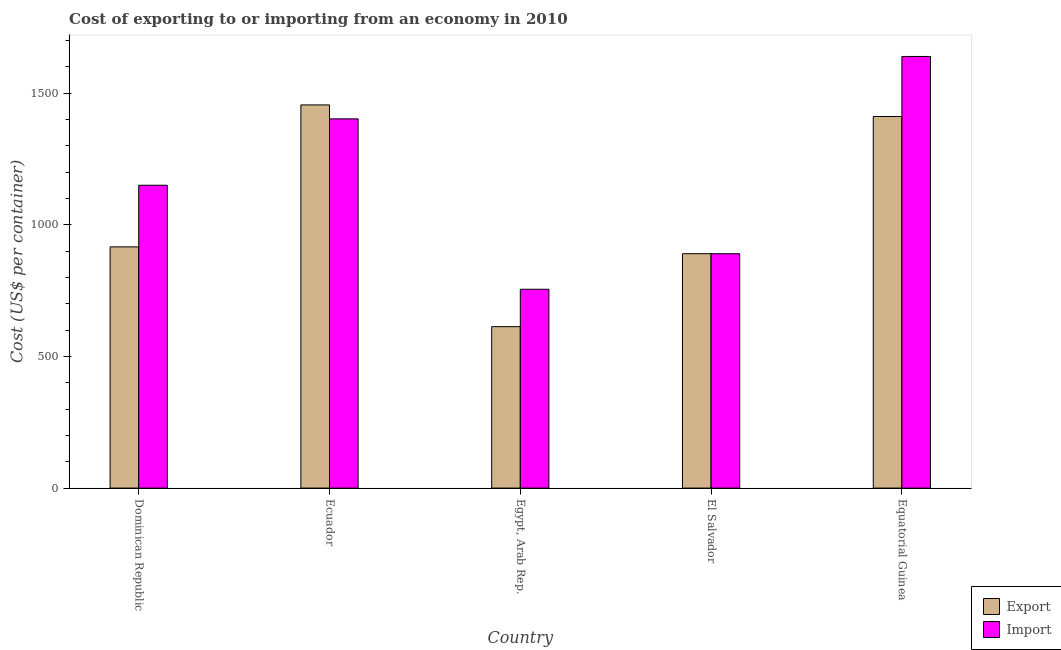How many different coloured bars are there?
Keep it short and to the point. 2. How many groups of bars are there?
Keep it short and to the point. 5. Are the number of bars per tick equal to the number of legend labels?
Ensure brevity in your answer.  Yes. Are the number of bars on each tick of the X-axis equal?
Give a very brief answer. Yes. How many bars are there on the 3rd tick from the left?
Give a very brief answer. 2. How many bars are there on the 4th tick from the right?
Your answer should be compact. 2. What is the label of the 4th group of bars from the left?
Make the answer very short. El Salvador. What is the import cost in Ecuador?
Give a very brief answer. 1402. Across all countries, what is the maximum export cost?
Give a very brief answer. 1455. Across all countries, what is the minimum export cost?
Make the answer very short. 613. In which country was the export cost maximum?
Your answer should be compact. Ecuador. In which country was the export cost minimum?
Your response must be concise. Egypt, Arab Rep. What is the total export cost in the graph?
Provide a succinct answer. 5285. What is the difference between the export cost in Ecuador and that in El Salvador?
Offer a terse response. 565. What is the difference between the export cost in El Salvador and the import cost in Dominican Republic?
Keep it short and to the point. -260. What is the average export cost per country?
Your answer should be very brief. 1057. What is the difference between the export cost and import cost in Egypt, Arab Rep.?
Ensure brevity in your answer.  -142. What is the ratio of the import cost in Ecuador to that in El Salvador?
Give a very brief answer. 1.58. Is the difference between the import cost in El Salvador and Equatorial Guinea greater than the difference between the export cost in El Salvador and Equatorial Guinea?
Offer a very short reply. No. What is the difference between the highest and the second highest import cost?
Your response must be concise. 237. What is the difference between the highest and the lowest export cost?
Your response must be concise. 842. In how many countries, is the import cost greater than the average import cost taken over all countries?
Offer a very short reply. 2. Is the sum of the import cost in Dominican Republic and El Salvador greater than the maximum export cost across all countries?
Your response must be concise. Yes. What does the 1st bar from the left in Dominican Republic represents?
Keep it short and to the point. Export. What does the 2nd bar from the right in El Salvador represents?
Offer a very short reply. Export. How many bars are there?
Provide a short and direct response. 10. Does the graph contain any zero values?
Your answer should be very brief. No. Where does the legend appear in the graph?
Provide a succinct answer. Bottom right. How many legend labels are there?
Ensure brevity in your answer.  2. What is the title of the graph?
Your answer should be compact. Cost of exporting to or importing from an economy in 2010. Does "Arms imports" appear as one of the legend labels in the graph?
Your response must be concise. No. What is the label or title of the X-axis?
Ensure brevity in your answer.  Country. What is the label or title of the Y-axis?
Your response must be concise. Cost (US$ per container). What is the Cost (US$ per container) of Export in Dominican Republic?
Provide a short and direct response. 916. What is the Cost (US$ per container) of Import in Dominican Republic?
Give a very brief answer. 1150. What is the Cost (US$ per container) of Export in Ecuador?
Offer a terse response. 1455. What is the Cost (US$ per container) in Import in Ecuador?
Offer a terse response. 1402. What is the Cost (US$ per container) in Export in Egypt, Arab Rep.?
Your answer should be compact. 613. What is the Cost (US$ per container) in Import in Egypt, Arab Rep.?
Ensure brevity in your answer.  755. What is the Cost (US$ per container) in Export in El Salvador?
Give a very brief answer. 890. What is the Cost (US$ per container) of Import in El Salvador?
Offer a terse response. 890. What is the Cost (US$ per container) in Export in Equatorial Guinea?
Your answer should be very brief. 1411. What is the Cost (US$ per container) of Import in Equatorial Guinea?
Ensure brevity in your answer.  1639. Across all countries, what is the maximum Cost (US$ per container) in Export?
Ensure brevity in your answer.  1455. Across all countries, what is the maximum Cost (US$ per container) in Import?
Give a very brief answer. 1639. Across all countries, what is the minimum Cost (US$ per container) in Export?
Offer a terse response. 613. Across all countries, what is the minimum Cost (US$ per container) in Import?
Ensure brevity in your answer.  755. What is the total Cost (US$ per container) in Export in the graph?
Offer a terse response. 5285. What is the total Cost (US$ per container) in Import in the graph?
Make the answer very short. 5836. What is the difference between the Cost (US$ per container) in Export in Dominican Republic and that in Ecuador?
Make the answer very short. -539. What is the difference between the Cost (US$ per container) in Import in Dominican Republic and that in Ecuador?
Ensure brevity in your answer.  -252. What is the difference between the Cost (US$ per container) in Export in Dominican Republic and that in Egypt, Arab Rep.?
Ensure brevity in your answer.  303. What is the difference between the Cost (US$ per container) of Import in Dominican Republic and that in Egypt, Arab Rep.?
Provide a short and direct response. 395. What is the difference between the Cost (US$ per container) in Import in Dominican Republic and that in El Salvador?
Give a very brief answer. 260. What is the difference between the Cost (US$ per container) of Export in Dominican Republic and that in Equatorial Guinea?
Keep it short and to the point. -495. What is the difference between the Cost (US$ per container) in Import in Dominican Republic and that in Equatorial Guinea?
Make the answer very short. -489. What is the difference between the Cost (US$ per container) in Export in Ecuador and that in Egypt, Arab Rep.?
Your answer should be very brief. 842. What is the difference between the Cost (US$ per container) in Import in Ecuador and that in Egypt, Arab Rep.?
Make the answer very short. 647. What is the difference between the Cost (US$ per container) of Export in Ecuador and that in El Salvador?
Your response must be concise. 565. What is the difference between the Cost (US$ per container) of Import in Ecuador and that in El Salvador?
Give a very brief answer. 512. What is the difference between the Cost (US$ per container) in Import in Ecuador and that in Equatorial Guinea?
Ensure brevity in your answer.  -237. What is the difference between the Cost (US$ per container) in Export in Egypt, Arab Rep. and that in El Salvador?
Your answer should be compact. -277. What is the difference between the Cost (US$ per container) in Import in Egypt, Arab Rep. and that in El Salvador?
Your answer should be very brief. -135. What is the difference between the Cost (US$ per container) of Export in Egypt, Arab Rep. and that in Equatorial Guinea?
Offer a very short reply. -798. What is the difference between the Cost (US$ per container) in Import in Egypt, Arab Rep. and that in Equatorial Guinea?
Provide a succinct answer. -884. What is the difference between the Cost (US$ per container) in Export in El Salvador and that in Equatorial Guinea?
Your response must be concise. -521. What is the difference between the Cost (US$ per container) of Import in El Salvador and that in Equatorial Guinea?
Provide a succinct answer. -749. What is the difference between the Cost (US$ per container) of Export in Dominican Republic and the Cost (US$ per container) of Import in Ecuador?
Your answer should be very brief. -486. What is the difference between the Cost (US$ per container) of Export in Dominican Republic and the Cost (US$ per container) of Import in Egypt, Arab Rep.?
Make the answer very short. 161. What is the difference between the Cost (US$ per container) in Export in Dominican Republic and the Cost (US$ per container) in Import in Equatorial Guinea?
Your answer should be compact. -723. What is the difference between the Cost (US$ per container) of Export in Ecuador and the Cost (US$ per container) of Import in Egypt, Arab Rep.?
Ensure brevity in your answer.  700. What is the difference between the Cost (US$ per container) in Export in Ecuador and the Cost (US$ per container) in Import in El Salvador?
Make the answer very short. 565. What is the difference between the Cost (US$ per container) in Export in Ecuador and the Cost (US$ per container) in Import in Equatorial Guinea?
Your response must be concise. -184. What is the difference between the Cost (US$ per container) of Export in Egypt, Arab Rep. and the Cost (US$ per container) of Import in El Salvador?
Offer a very short reply. -277. What is the difference between the Cost (US$ per container) of Export in Egypt, Arab Rep. and the Cost (US$ per container) of Import in Equatorial Guinea?
Your response must be concise. -1026. What is the difference between the Cost (US$ per container) of Export in El Salvador and the Cost (US$ per container) of Import in Equatorial Guinea?
Provide a short and direct response. -749. What is the average Cost (US$ per container) in Export per country?
Provide a succinct answer. 1057. What is the average Cost (US$ per container) in Import per country?
Your answer should be very brief. 1167.2. What is the difference between the Cost (US$ per container) in Export and Cost (US$ per container) in Import in Dominican Republic?
Offer a terse response. -234. What is the difference between the Cost (US$ per container) in Export and Cost (US$ per container) in Import in Ecuador?
Offer a very short reply. 53. What is the difference between the Cost (US$ per container) in Export and Cost (US$ per container) in Import in Egypt, Arab Rep.?
Keep it short and to the point. -142. What is the difference between the Cost (US$ per container) of Export and Cost (US$ per container) of Import in Equatorial Guinea?
Provide a short and direct response. -228. What is the ratio of the Cost (US$ per container) of Export in Dominican Republic to that in Ecuador?
Ensure brevity in your answer.  0.63. What is the ratio of the Cost (US$ per container) of Import in Dominican Republic to that in Ecuador?
Your answer should be compact. 0.82. What is the ratio of the Cost (US$ per container) of Export in Dominican Republic to that in Egypt, Arab Rep.?
Your response must be concise. 1.49. What is the ratio of the Cost (US$ per container) of Import in Dominican Republic to that in Egypt, Arab Rep.?
Offer a terse response. 1.52. What is the ratio of the Cost (US$ per container) in Export in Dominican Republic to that in El Salvador?
Give a very brief answer. 1.03. What is the ratio of the Cost (US$ per container) of Import in Dominican Republic to that in El Salvador?
Offer a very short reply. 1.29. What is the ratio of the Cost (US$ per container) in Export in Dominican Republic to that in Equatorial Guinea?
Your answer should be very brief. 0.65. What is the ratio of the Cost (US$ per container) in Import in Dominican Republic to that in Equatorial Guinea?
Give a very brief answer. 0.7. What is the ratio of the Cost (US$ per container) of Export in Ecuador to that in Egypt, Arab Rep.?
Keep it short and to the point. 2.37. What is the ratio of the Cost (US$ per container) in Import in Ecuador to that in Egypt, Arab Rep.?
Give a very brief answer. 1.86. What is the ratio of the Cost (US$ per container) of Export in Ecuador to that in El Salvador?
Keep it short and to the point. 1.63. What is the ratio of the Cost (US$ per container) of Import in Ecuador to that in El Salvador?
Ensure brevity in your answer.  1.58. What is the ratio of the Cost (US$ per container) of Export in Ecuador to that in Equatorial Guinea?
Provide a succinct answer. 1.03. What is the ratio of the Cost (US$ per container) of Import in Ecuador to that in Equatorial Guinea?
Provide a succinct answer. 0.86. What is the ratio of the Cost (US$ per container) of Export in Egypt, Arab Rep. to that in El Salvador?
Make the answer very short. 0.69. What is the ratio of the Cost (US$ per container) in Import in Egypt, Arab Rep. to that in El Salvador?
Offer a very short reply. 0.85. What is the ratio of the Cost (US$ per container) in Export in Egypt, Arab Rep. to that in Equatorial Guinea?
Provide a short and direct response. 0.43. What is the ratio of the Cost (US$ per container) of Import in Egypt, Arab Rep. to that in Equatorial Guinea?
Provide a short and direct response. 0.46. What is the ratio of the Cost (US$ per container) of Export in El Salvador to that in Equatorial Guinea?
Provide a succinct answer. 0.63. What is the ratio of the Cost (US$ per container) of Import in El Salvador to that in Equatorial Guinea?
Your answer should be very brief. 0.54. What is the difference between the highest and the second highest Cost (US$ per container) in Import?
Offer a very short reply. 237. What is the difference between the highest and the lowest Cost (US$ per container) in Export?
Offer a terse response. 842. What is the difference between the highest and the lowest Cost (US$ per container) of Import?
Provide a short and direct response. 884. 